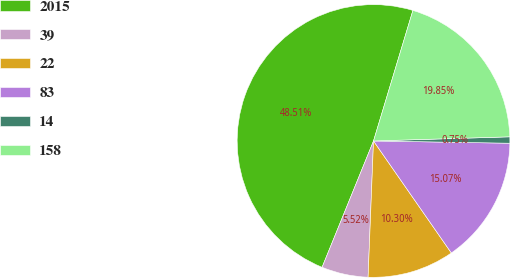Convert chart. <chart><loc_0><loc_0><loc_500><loc_500><pie_chart><fcel>2015<fcel>39<fcel>22<fcel>83<fcel>14<fcel>158<nl><fcel>48.51%<fcel>5.52%<fcel>10.3%<fcel>15.07%<fcel>0.75%<fcel>19.85%<nl></chart> 